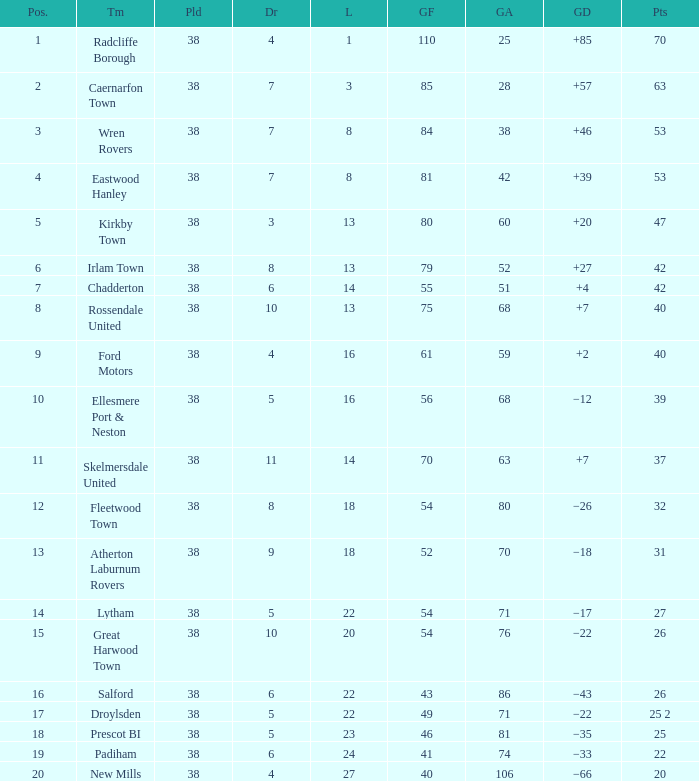Which Position has Goals For of 52, and Goals Against larger than 70? None. 